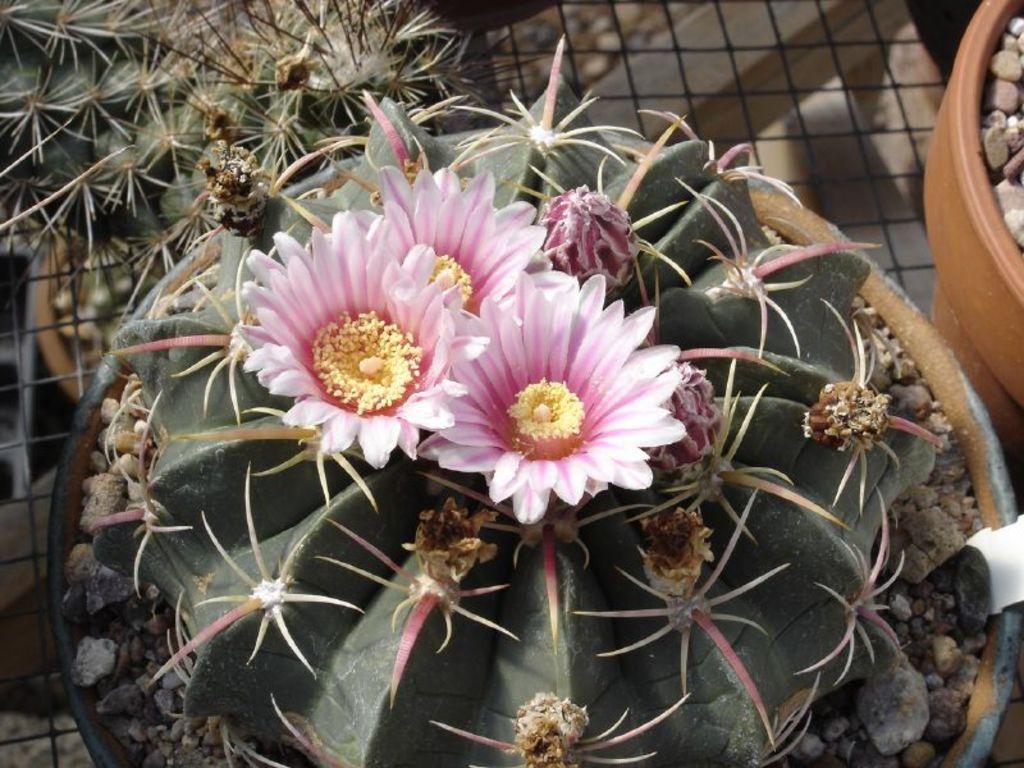Describe this image in one or two sentences. In this image there are pot plants, rocks, flowers and mesh. 